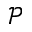<formula> <loc_0><loc_0><loc_500><loc_500>\mathcal { P }</formula> 